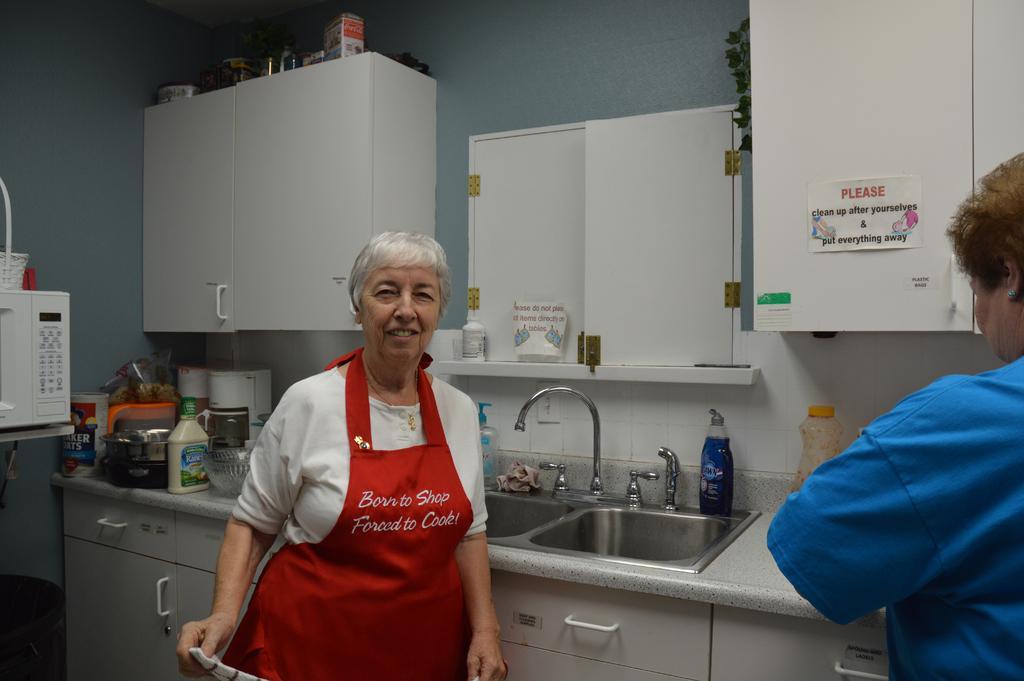Could you give a brief overview of what you see in this image? In this picture I see 2 women in front and in the background I see the cupboards on the wall and I see many things on the counter top and I see the wash basin and I see a paper on this cupboard which is on the right side and I see something is written on it. 